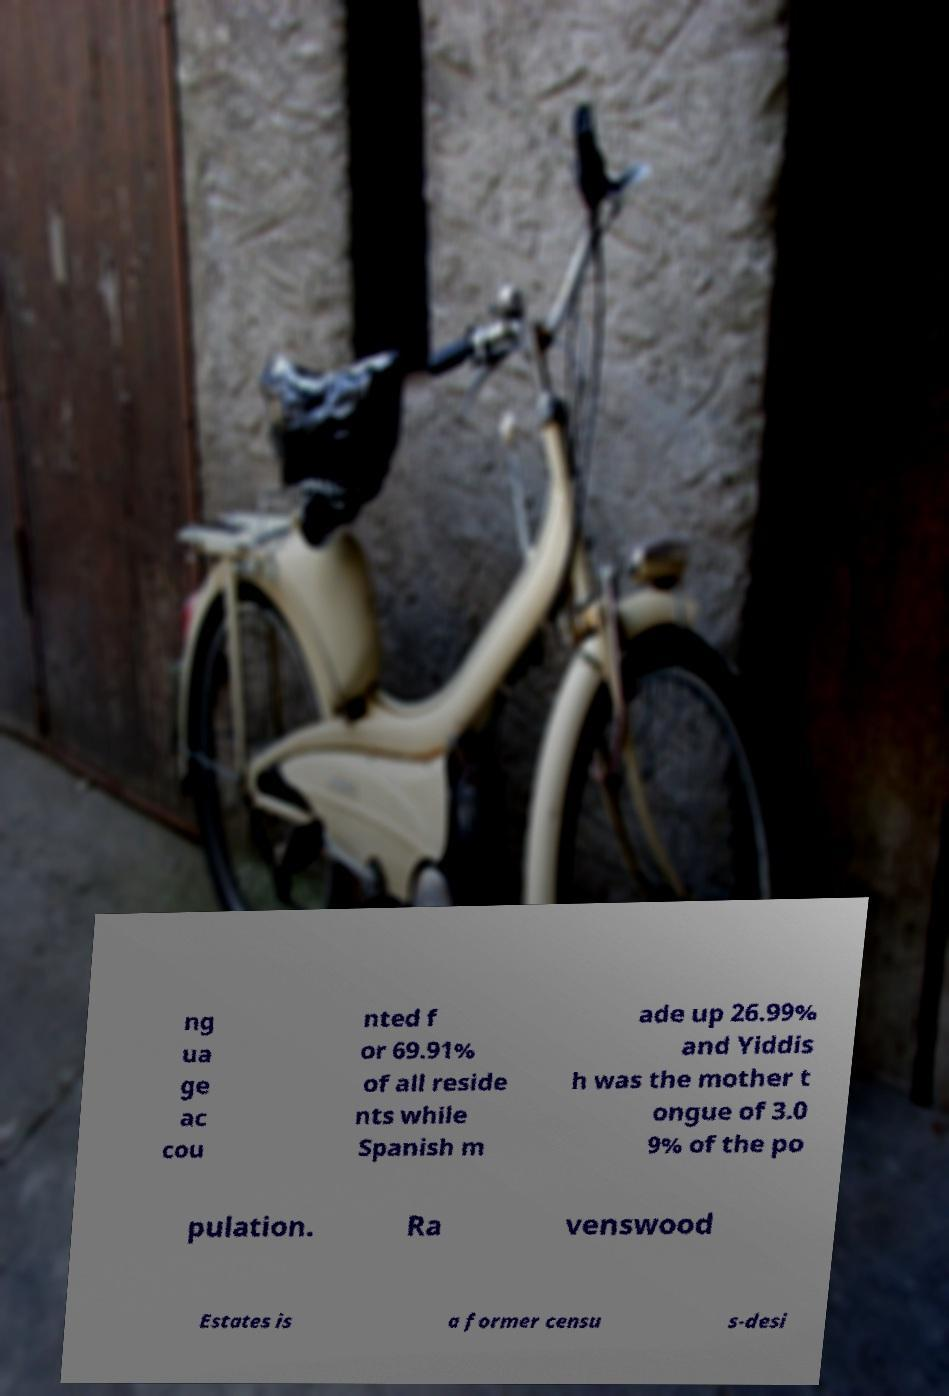What messages or text are displayed in this image? I need them in a readable, typed format. ng ua ge ac cou nted f or 69.91% of all reside nts while Spanish m ade up 26.99% and Yiddis h was the mother t ongue of 3.0 9% of the po pulation. Ra venswood Estates is a former censu s-desi 